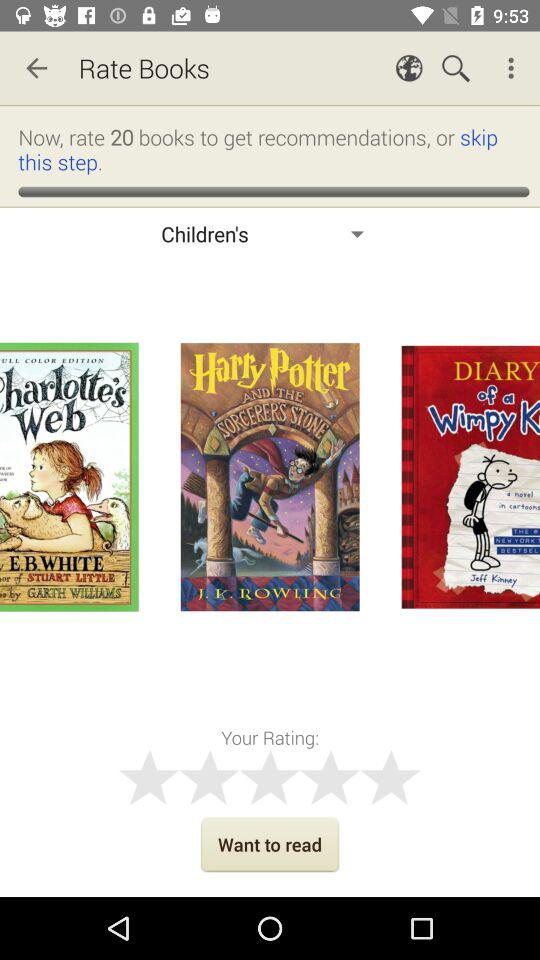Who wrote the book "Harry Potter"? The book "Harry Potter" was written by J.K. Rowling. 